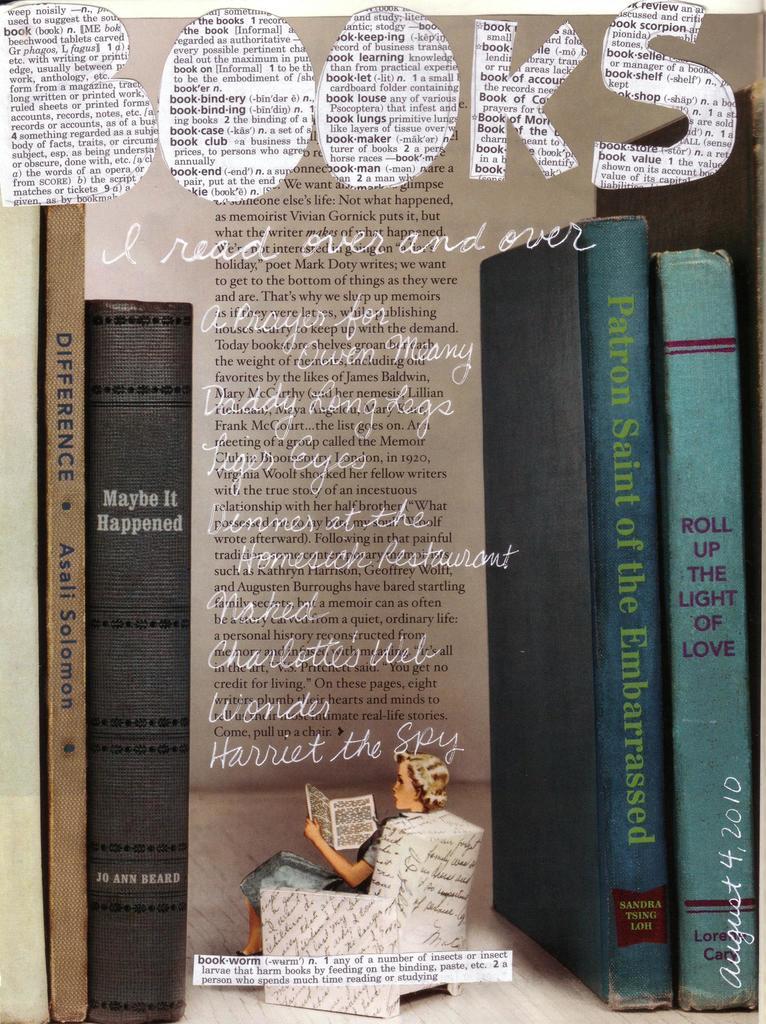Who wrote maybe it happened?
Your response must be concise. Jo ann beard. What is the name of the book on the very right?
Offer a terse response. Roll up the light of love. 